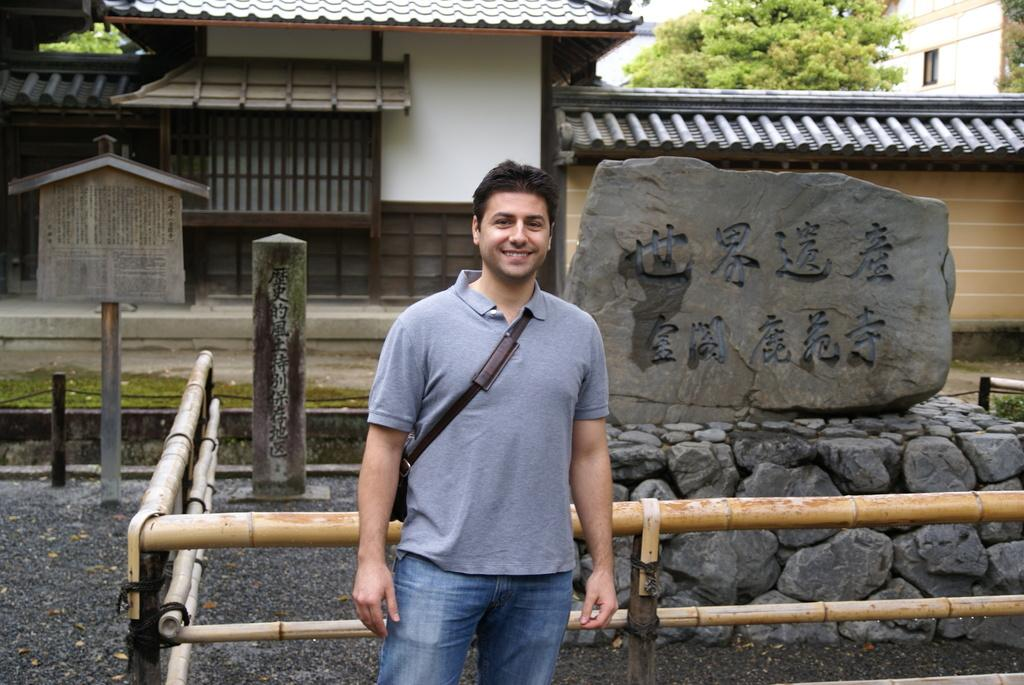What is the person in the image doing? The person is standing on the road. What can be seen in the background of the image? There is a fence, a stone sculpture, buildings, trees, and the sky visible in the background. Can you describe the time of day when the image was taken? The image appears to be taken during the day. What type of waste is being disposed of in the image? There is no waste present in the image. What is the cause of the person's presence in the image? The image does not provide information about the reason for the person's presence, so we cannot determine the cause. 